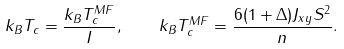<formula> <loc_0><loc_0><loc_500><loc_500>k _ { B } T _ { c } = \frac { k _ { B } T _ { c } ^ { M F } } { I } , \quad k _ { B } T _ { c } ^ { M F } = \frac { 6 ( 1 + \Delta ) J _ { x y } S ^ { 2 } } { n } .</formula> 